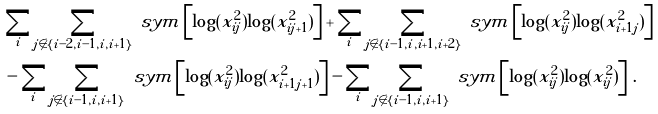Convert formula to latex. <formula><loc_0><loc_0><loc_500><loc_500>& \sum _ { i } \sum _ { j \not \in \{ i - 2 , i - 1 , i , i + 1 \} } \ s y m \left [ \log ( x _ { i j } ^ { 2 } ) \log ( x _ { i j + 1 } ^ { 2 } ) \right ] + \sum _ { i } \sum _ { j \not \in \{ i - 1 , i , i + 1 , i + 2 \} } \ s y m \left [ \log ( x _ { i j } ^ { 2 } ) \log ( x _ { i + 1 j } ^ { 2 } ) \right ] \\ & - \sum _ { i } \sum _ { j \not \in \{ i - 1 , i , i + 1 \} } \ s y m \left [ \log ( x _ { i j } ^ { 2 } ) \log ( x _ { i + 1 j + 1 } ^ { 2 } ) \right ] - \sum _ { i } \sum _ { j \not \in \{ i - 1 , i , i + 1 \} } \ s y m \left [ \log ( x _ { i j } ^ { 2 } ) \log ( x _ { i j } ^ { 2 } ) \right ] \, .</formula> 